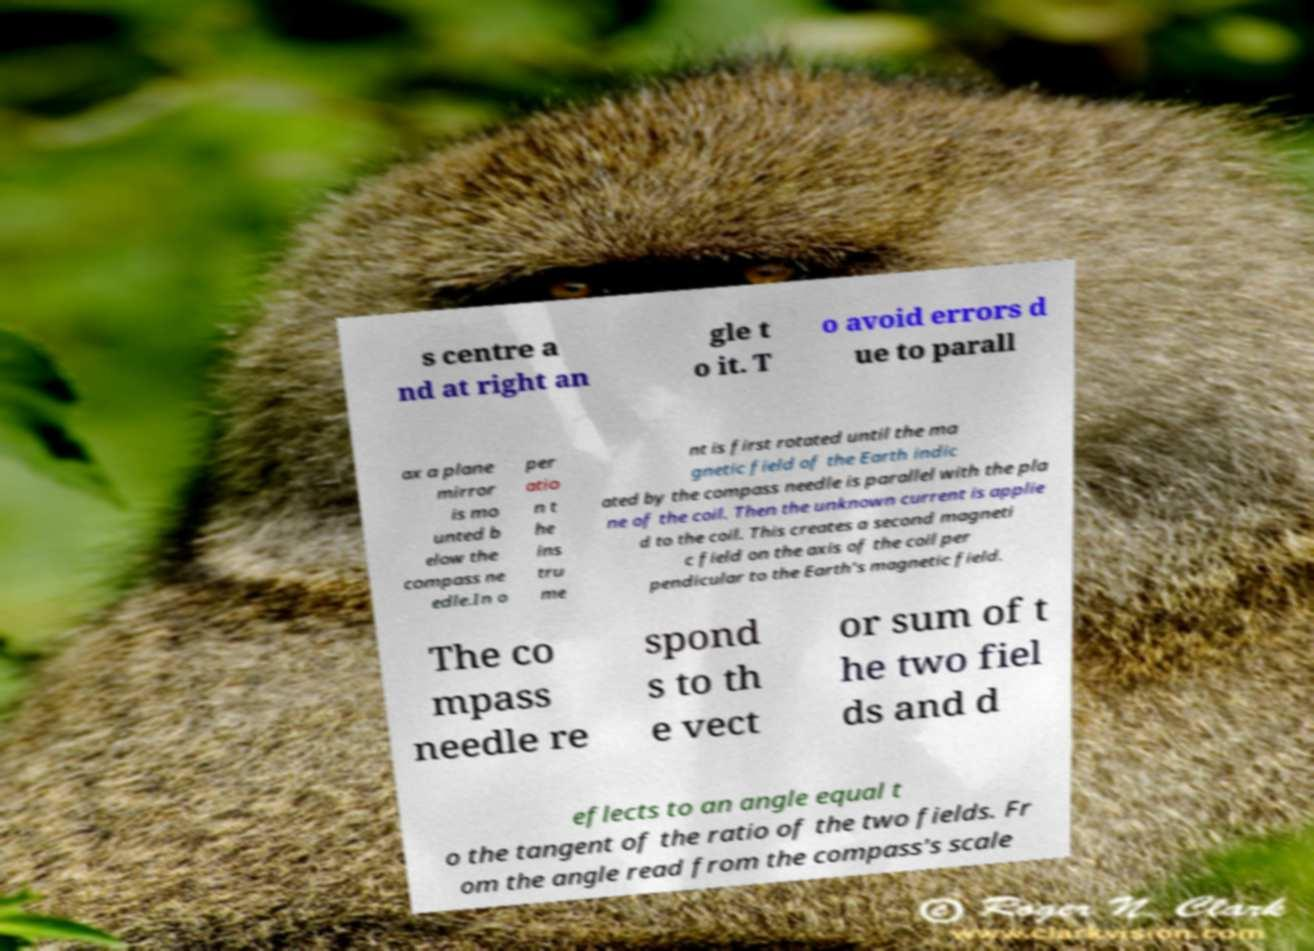Could you extract and type out the text from this image? s centre a nd at right an gle t o it. T o avoid errors d ue to parall ax a plane mirror is mo unted b elow the compass ne edle.In o per atio n t he ins tru me nt is first rotated until the ma gnetic field of the Earth indic ated by the compass needle is parallel with the pla ne of the coil. Then the unknown current is applie d to the coil. This creates a second magneti c field on the axis of the coil per pendicular to the Earth's magnetic field. The co mpass needle re spond s to th e vect or sum of t he two fiel ds and d eflects to an angle equal t o the tangent of the ratio of the two fields. Fr om the angle read from the compass's scale 